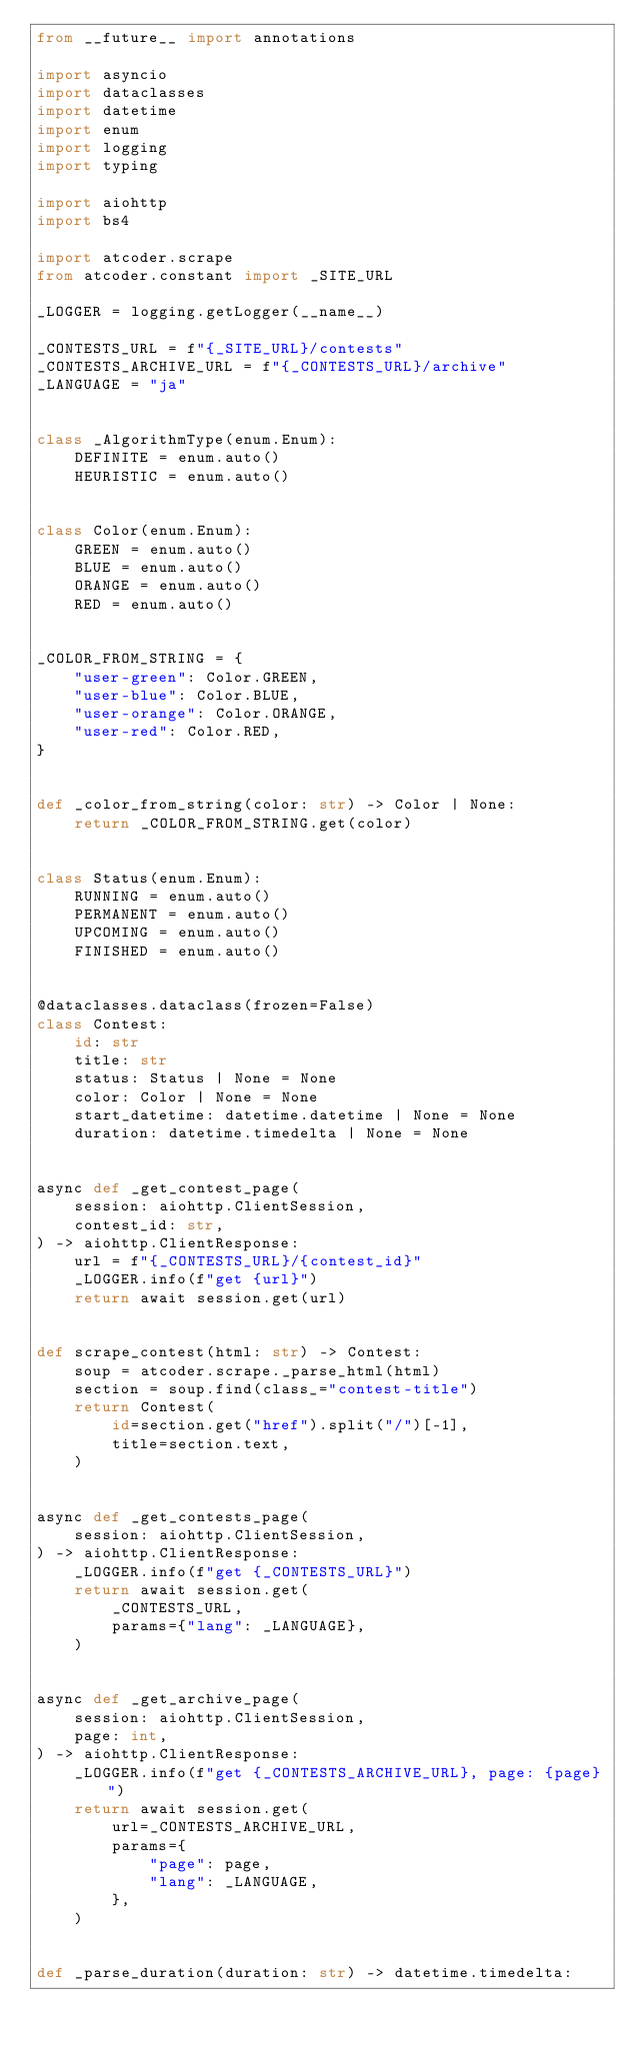<code> <loc_0><loc_0><loc_500><loc_500><_Python_>from __future__ import annotations

import asyncio
import dataclasses
import datetime
import enum
import logging
import typing

import aiohttp
import bs4

import atcoder.scrape
from atcoder.constant import _SITE_URL

_LOGGER = logging.getLogger(__name__)

_CONTESTS_URL = f"{_SITE_URL}/contests"
_CONTESTS_ARCHIVE_URL = f"{_CONTESTS_URL}/archive"
_LANGUAGE = "ja"


class _AlgorithmType(enum.Enum):
    DEFINITE = enum.auto()
    HEURISTIC = enum.auto()


class Color(enum.Enum):
    GREEN = enum.auto()
    BLUE = enum.auto()
    ORANGE = enum.auto()
    RED = enum.auto()


_COLOR_FROM_STRING = {
    "user-green": Color.GREEN,
    "user-blue": Color.BLUE,
    "user-orange": Color.ORANGE,
    "user-red": Color.RED,
}


def _color_from_string(color: str) -> Color | None:
    return _COLOR_FROM_STRING.get(color)


class Status(enum.Enum):
    RUNNING = enum.auto()
    PERMANENT = enum.auto()
    UPCOMING = enum.auto()
    FINISHED = enum.auto()


@dataclasses.dataclass(frozen=False)
class Contest:
    id: str
    title: str
    status: Status | None = None
    color: Color | None = None
    start_datetime: datetime.datetime | None = None
    duration: datetime.timedelta | None = None


async def _get_contest_page(
    session: aiohttp.ClientSession,
    contest_id: str,
) -> aiohttp.ClientResponse:
    url = f"{_CONTESTS_URL}/{contest_id}"
    _LOGGER.info(f"get {url}")
    return await session.get(url)


def scrape_contest(html: str) -> Contest:
    soup = atcoder.scrape._parse_html(html)
    section = soup.find(class_="contest-title")
    return Contest(
        id=section.get("href").split("/")[-1],
        title=section.text,
    )


async def _get_contests_page(
    session: aiohttp.ClientSession,
) -> aiohttp.ClientResponse:
    _LOGGER.info(f"get {_CONTESTS_URL}")
    return await session.get(
        _CONTESTS_URL,
        params={"lang": _LANGUAGE},
    )


async def _get_archive_page(
    session: aiohttp.ClientSession,
    page: int,
) -> aiohttp.ClientResponse:
    _LOGGER.info(f"get {_CONTESTS_ARCHIVE_URL}, page: {page}")
    return await session.get(
        url=_CONTESTS_ARCHIVE_URL,
        params={
            "page": page,
            "lang": _LANGUAGE,
        },
    )


def _parse_duration(duration: str) -> datetime.timedelta:</code> 